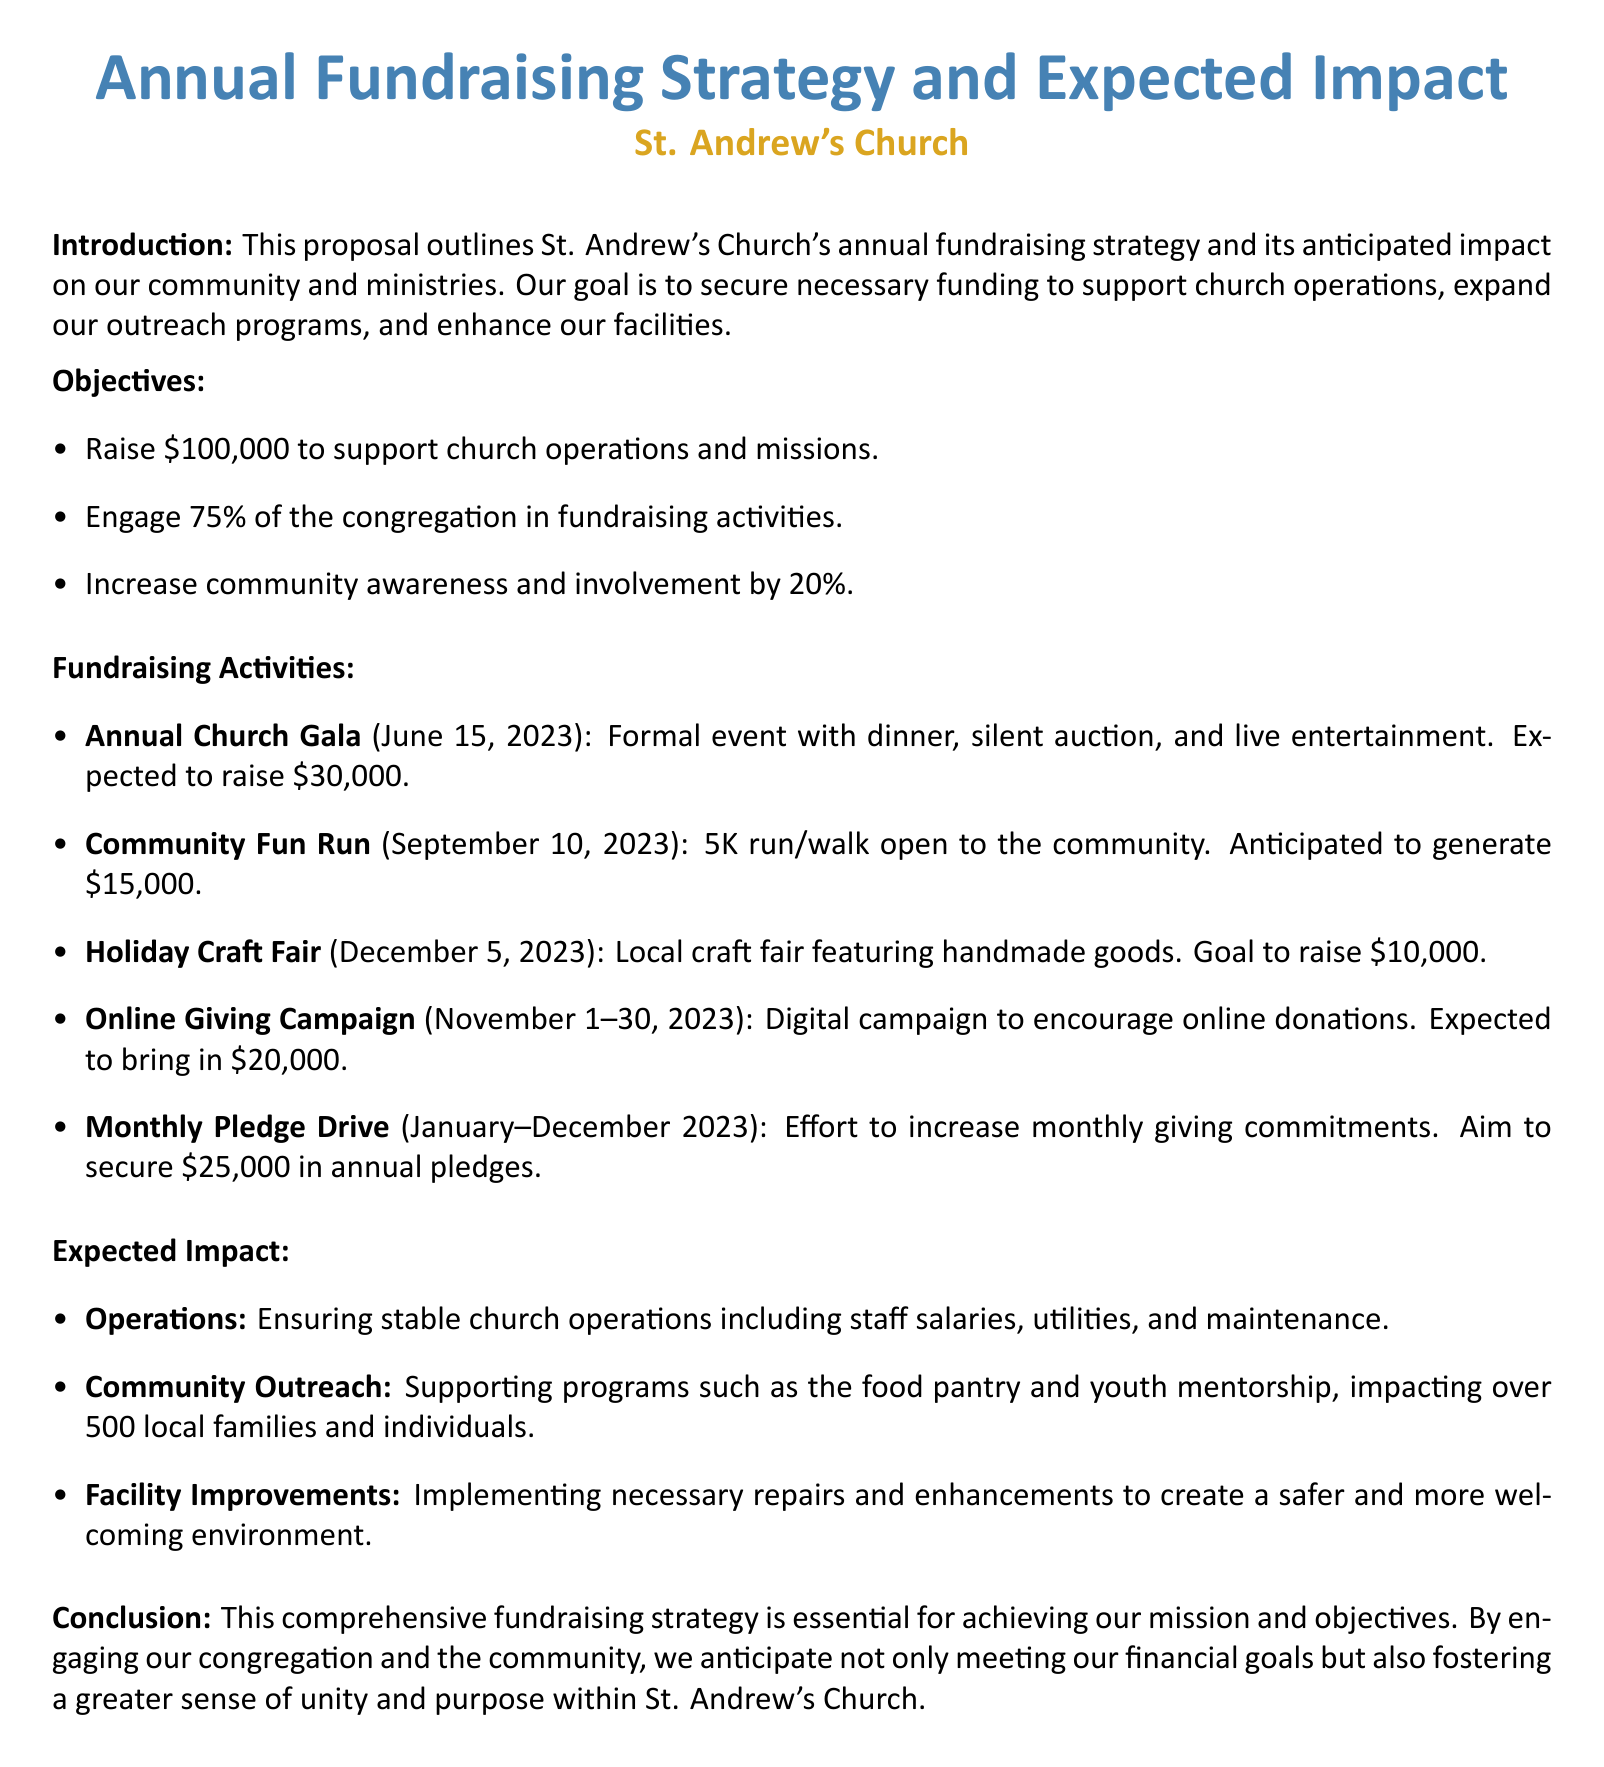What is the fundraising goal? The proposal states that the goal is to raise $100,000 to support church operations and missions.
Answer: $100,000 When is the Annual Church Gala scheduled? The document lists the Annual Church Gala date as June 15, 2023.
Answer: June 15, 2023 How much is expected to be raised from the Online Giving Campaign? The document specifies that the Online Giving Campaign is expected to bring in $20,000.
Answer: $20,000 What percentage of the congregation is aimed to be engaged in fundraising activities? The proposal mentions that the objective is to engage 75% of the congregation.
Answer: 75% How many local families and individuals will be impacted by community outreach programs? The expected impact section indicates that over 500 local families and individuals will be impacted.
Answer: 500 What is the anticipated revenue from the Community Fun Run? The proposal states that the Community Fun Run is anticipated to generate $15,000.
Answer: $15,000 Which facility improvement goal is mentioned in the expected impact section? The document notes the objective to implement necessary repairs and enhancements for a safer and more welcoming environment.
Answer: Safer and more welcoming environment What type of event is the Holiday Craft Fair? The document describes the Holiday Craft Fair as a local craft fair featuring handmade goods.
Answer: Local craft fair featuring handmade goods 